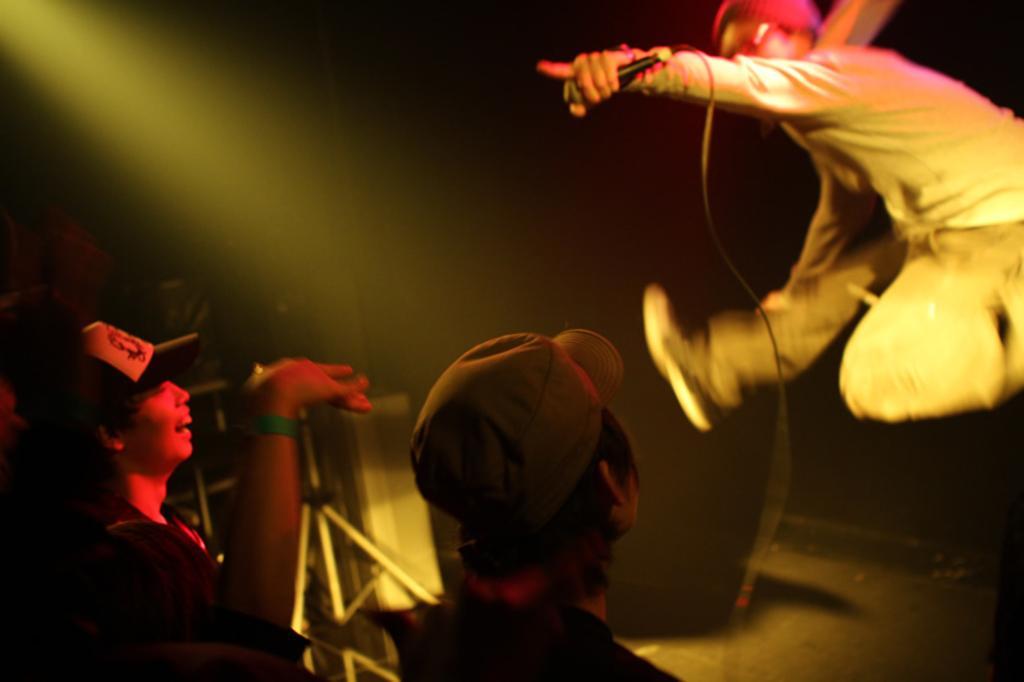Please provide a concise description of this image. In this image, we can see few people are wearing caps. Here a person is smiling. On the right side, we can see a person in the air and holding a microphone with wire. Background we can see rods, some objects. 